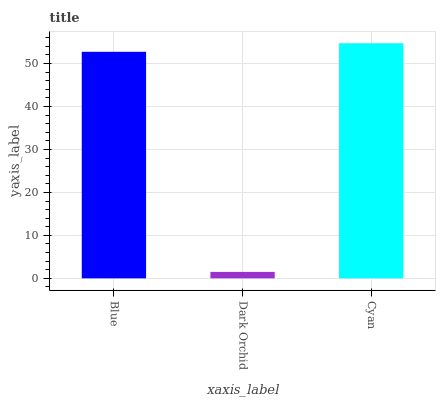Is Dark Orchid the minimum?
Answer yes or no. Yes. Is Cyan the maximum?
Answer yes or no. Yes. Is Cyan the minimum?
Answer yes or no. No. Is Dark Orchid the maximum?
Answer yes or no. No. Is Cyan greater than Dark Orchid?
Answer yes or no. Yes. Is Dark Orchid less than Cyan?
Answer yes or no. Yes. Is Dark Orchid greater than Cyan?
Answer yes or no. No. Is Cyan less than Dark Orchid?
Answer yes or no. No. Is Blue the high median?
Answer yes or no. Yes. Is Blue the low median?
Answer yes or no. Yes. Is Cyan the high median?
Answer yes or no. No. Is Dark Orchid the low median?
Answer yes or no. No. 